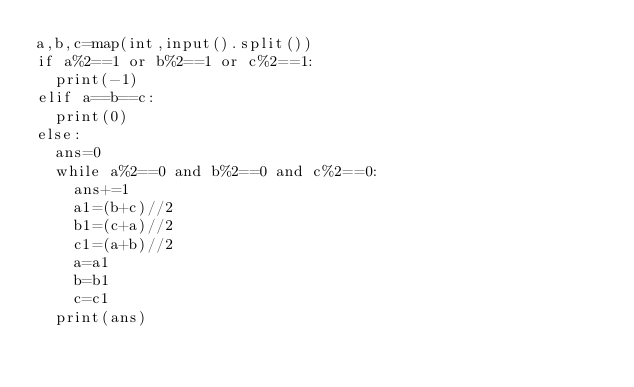Convert code to text. <code><loc_0><loc_0><loc_500><loc_500><_Python_>a,b,c=map(int,input().split())
if a%2==1 or b%2==1 or c%2==1:
  print(-1)
elif a==b==c:
  print(0)
else:
  ans=0
  while a%2==0 and b%2==0 and c%2==0:
    ans+=1
    a1=(b+c)//2
    b1=(c+a)//2
    c1=(a+b)//2
    a=a1
    b=b1
    c=c1
  print(ans)</code> 